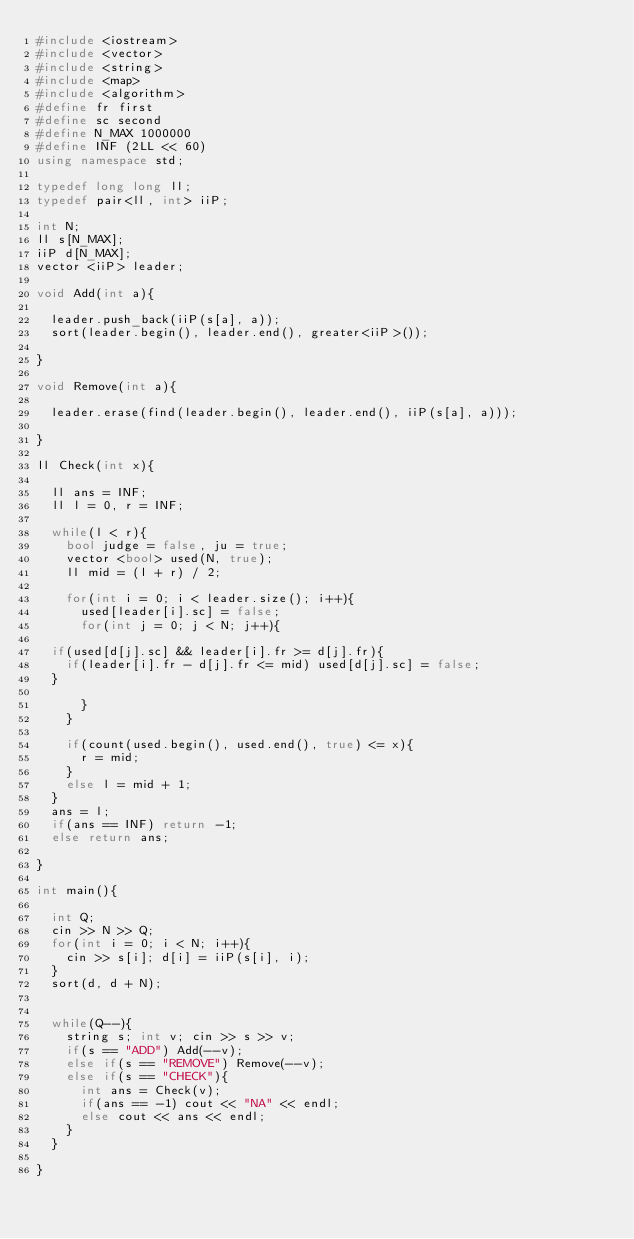<code> <loc_0><loc_0><loc_500><loc_500><_C++_>#include <iostream>
#include <vector>
#include <string>
#include <map>
#include <algorithm>
#define fr first
#define sc second
#define N_MAX 1000000
#define INF (2LL << 60)
using namespace std;

typedef long long ll;
typedef pair<ll, int> iiP;

int N;
ll s[N_MAX];
iiP d[N_MAX];
vector <iiP> leader;

void Add(int a){
 
  leader.push_back(iiP(s[a], a));
  sort(leader.begin(), leader.end(), greater<iiP>());

}

void Remove(int a){
  
  leader.erase(find(leader.begin(), leader.end(), iiP(s[a], a)));

}

ll Check(int x){
  
  ll ans = INF;
  ll l = 0, r = INF;

  while(l < r){
    bool judge = false, ju = true;
    vector <bool> used(N, true);
    ll mid = (l + r) / 2;
    
    for(int i = 0; i < leader.size(); i++){
      used[leader[i].sc] = false;
      for(int j = 0; j < N; j++){
	
	if(used[d[j].sc] && leader[i].fr >= d[j].fr){
	  if(leader[i].fr - d[j].fr <= mid) used[d[j].sc] = false;
	}

      }
    }

    if(count(used.begin(), used.end(), true) <= x){
      r = mid;
    }
    else l = mid + 1;
  }
  ans = l;
  if(ans == INF) return -1;
  else return ans;
  
}

int main(){
  
  int Q;
  cin >> N >> Q;
  for(int i = 0; i < N; i++){
    cin >> s[i]; d[i] = iiP(s[i], i);
  }
  sort(d, d + N);
  
  
  while(Q--){
    string s; int v; cin >> s >> v;
    if(s == "ADD") Add(--v);
    else if(s == "REMOVE") Remove(--v);
    else if(s == "CHECK"){
      int ans = Check(v);
      if(ans == -1) cout << "NA" << endl;
      else cout << ans << endl;
    }
  }

}</code> 